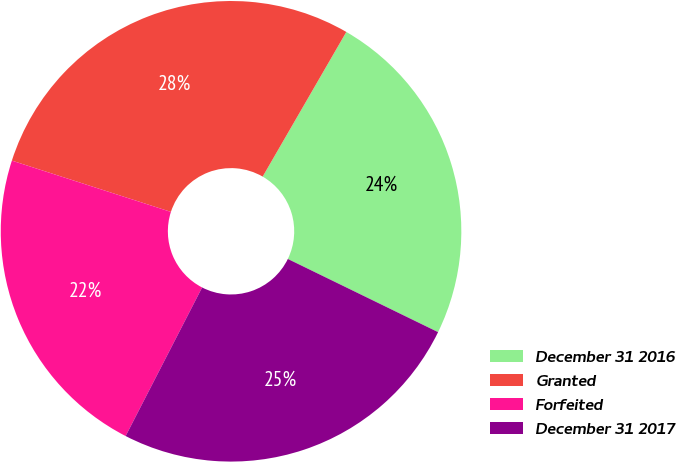Convert chart. <chart><loc_0><loc_0><loc_500><loc_500><pie_chart><fcel>December 31 2016<fcel>Granted<fcel>Forfeited<fcel>December 31 2017<nl><fcel>23.87%<fcel>28.38%<fcel>22.4%<fcel>25.35%<nl></chart> 